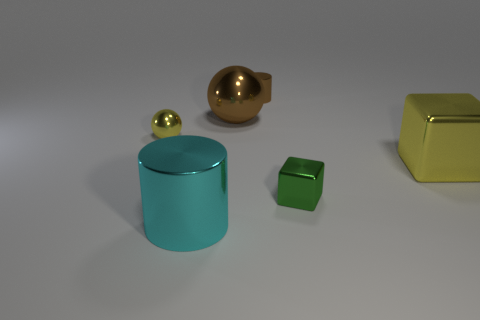Add 1 green matte spheres. How many objects exist? 7 Subtract all red balls. How many yellow cylinders are left? 0 Subtract 0 cyan spheres. How many objects are left? 6 Subtract all balls. How many objects are left? 4 Subtract all red blocks. Subtract all gray cylinders. How many blocks are left? 2 Subtract all big purple rubber objects. Subtract all spheres. How many objects are left? 4 Add 4 small metallic cylinders. How many small metallic cylinders are left? 5 Add 4 red shiny things. How many red shiny things exist? 4 